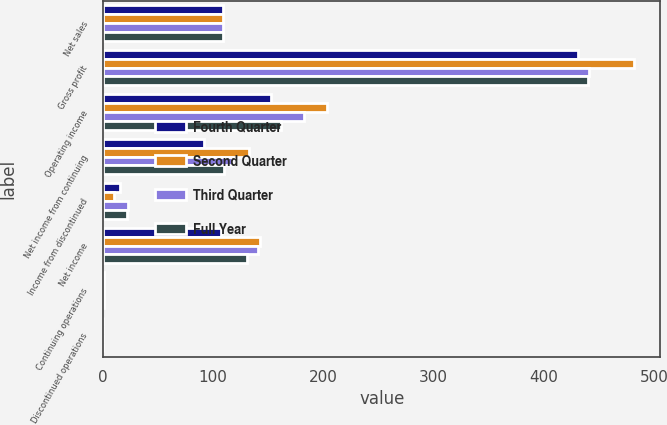Convert chart to OTSL. <chart><loc_0><loc_0><loc_500><loc_500><stacked_bar_chart><ecel><fcel>Net sales<fcel>Gross profit<fcel>Operating income<fcel>Net income from continuing<fcel>Income from discontinued<fcel>Net income<fcel>Continuing operations<fcel>Discontinued operations<nl><fcel>Fourth Quarter<fcel>108.5<fcel>431.3<fcel>152.7<fcel>91.8<fcel>15.6<fcel>107.4<fcel>0.5<fcel>0.09<nl><fcel>Second Quarter<fcel>108.5<fcel>481.8<fcel>203.4<fcel>132.7<fcel>10.1<fcel>142.8<fcel>0.73<fcel>0.06<nl><fcel>Third Quarter<fcel>108.5<fcel>440.9<fcel>182.8<fcel>117.5<fcel>22.9<fcel>141<fcel>0.65<fcel>0.13<nl><fcel>Full Year<fcel>108.5<fcel>440.1<fcel>161.8<fcel>109.6<fcel>21.4<fcel>131<fcel>0.6<fcel>0.12<nl></chart> 